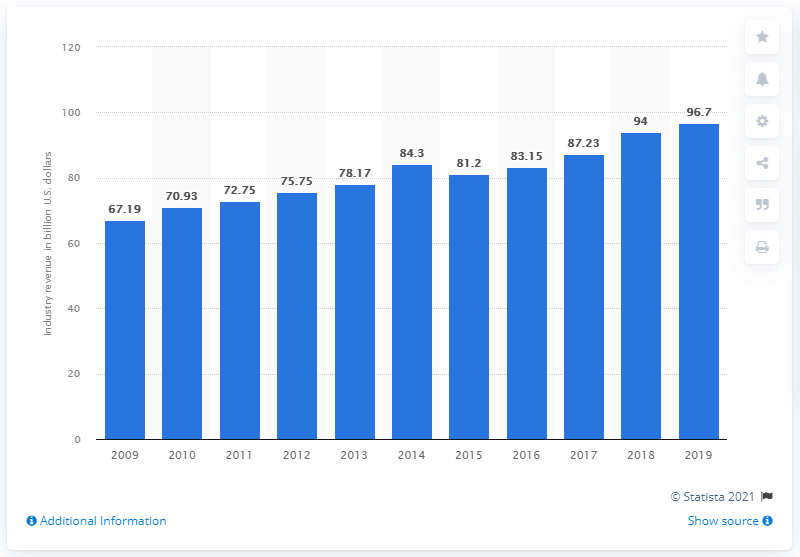Indicate a few pertinent items in this graphic. According to estimates, the revenue of the health and fitness club industry in 2019 was approximately 96.7 billion U.S. dollars. 